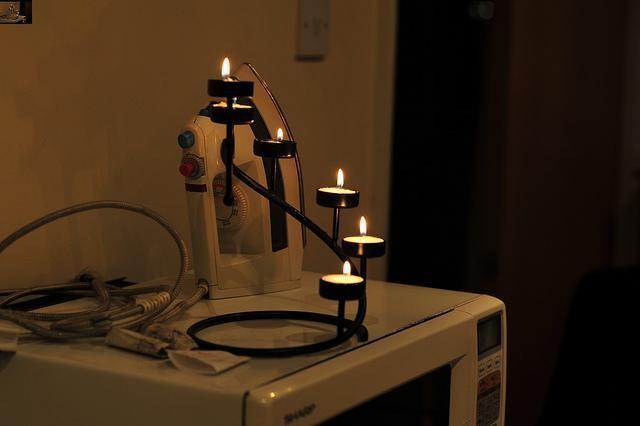How many candles are on?
Give a very brief answer. 6. How many candles are there?
Give a very brief answer. 6. How many carrots are on the table?
Give a very brief answer. 0. 